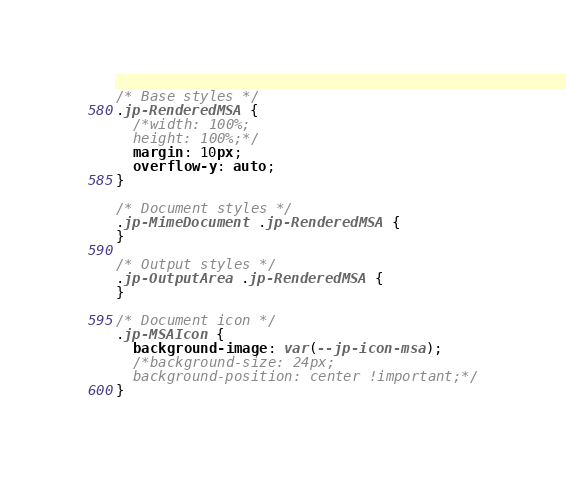Convert code to text. <code><loc_0><loc_0><loc_500><loc_500><_CSS_>/* Base styles */
.jp-RenderedMSA {
  /*width: 100%;
  height: 100%;*/
  margin: 10px;
  overflow-y: auto;
}

/* Document styles */
.jp-MimeDocument .jp-RenderedMSA {
}

/* Output styles */
.jp-OutputArea .jp-RenderedMSA {
}

/* Document icon */
.jp-MSAIcon {
  background-image: var(--jp-icon-msa);
  /*background-size: 24px;
  background-position: center !important;*/
}
</code> 